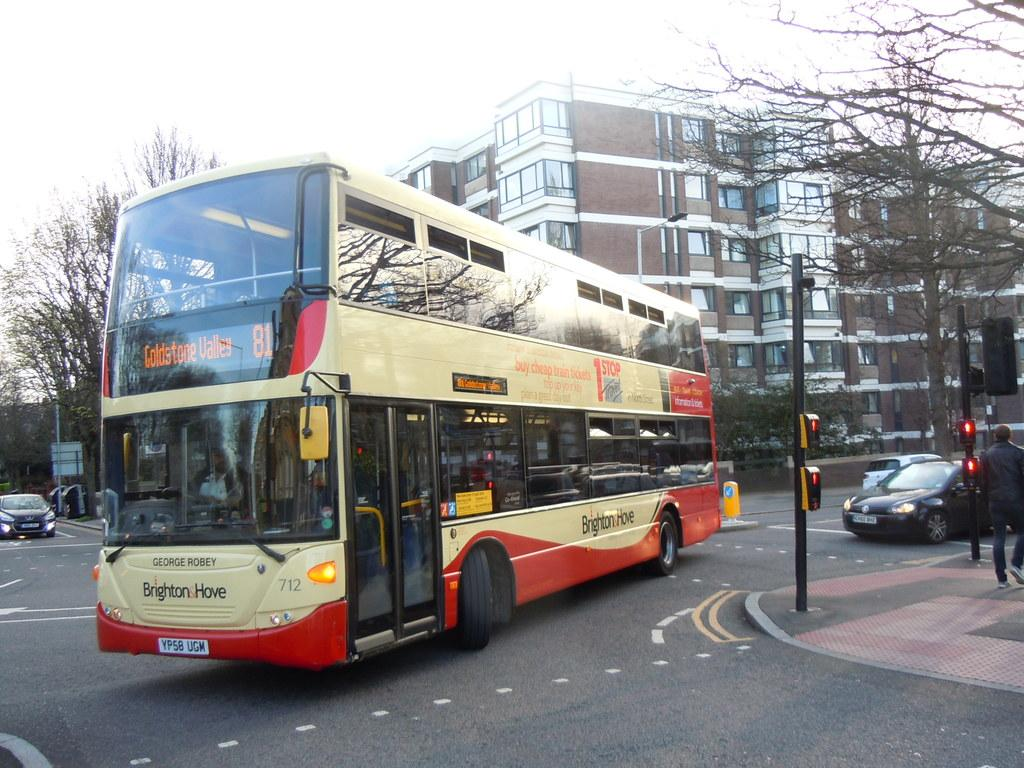What can be seen on the road in the image? There are vehicles on the road in the image. What is the person in the image doing? There is a person walking in the image. What helps regulate traffic in the image? There are traffic signals in the image. What type of structures can be seen in the image? There are buildings in the image. What type of vegetation is present in the image? There are trees in the image. What is visible in the sky in the image? The sky is visible in the image, and it appears to be white in color. What flavor of lead can be seen in the image? There is no lead present in the image, and therefore no flavor can be determined. What type of lock is used to secure the trees in the image? There are no locks present on the trees in the image. 